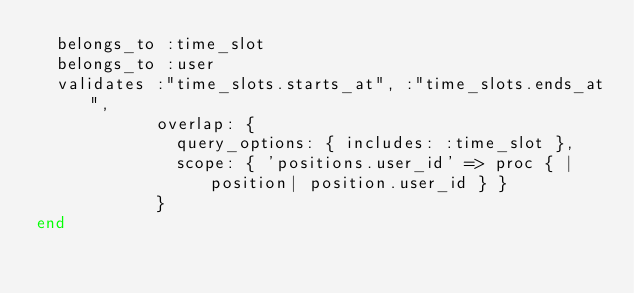<code> <loc_0><loc_0><loc_500><loc_500><_Ruby_>  belongs_to :time_slot
  belongs_to :user
  validates :"time_slots.starts_at", :"time_slots.ends_at",
            overlap: {
              query_options: { includes: :time_slot },
              scope: { 'positions.user_id' => proc { |position| position.user_id } }
            }
end
</code> 